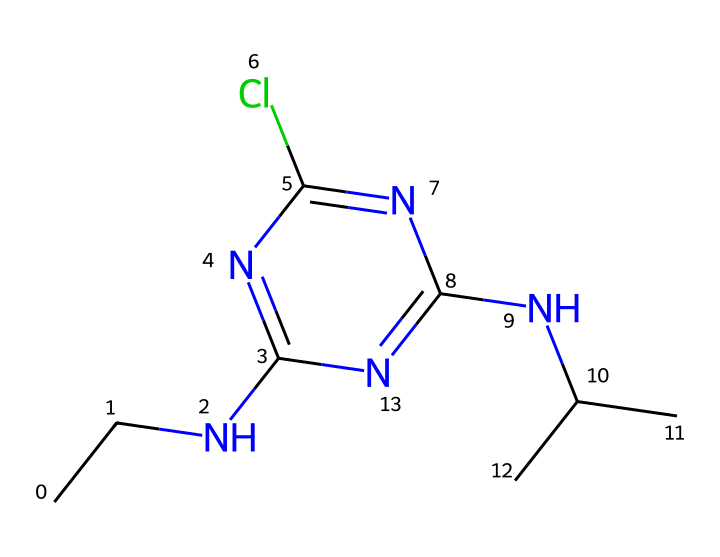What is the molecular formula of atrazine? The molecular formula can be deduced by counting the types and number of atoms represented in the SMILES. The structure shows carbon (C), hydrogen (H), chlorine (Cl), and nitrogen (N) atoms, which combine to form C8H14ClN5.
Answer: C8H14ClN5 How many nitrogen atoms are in the structure? By analyzing the SMILES, we identify five 'N' characters, indicating there are five nitrogen atoms present in the molecule.
Answer: 5 What type of chemical bond is indicated between the carbon atoms in this herbicide? The presence of directly connected carbon atoms in the SMILES suggests that these carbon atoms are linked by single covalent bonds, as there are no double or triple bond indications between them in the representation.
Answer: single covalent bonds What is the significance of the chlorine atom in atrazine? The chlorine atom is known to enhance the herbicide's ability to inhibit photosynthesis and is an important functional group in herbicides, particularly for atrazine's activity against weeds.
Answer: enhances herbicidal activity Which chemical functional group is primarily responsible for atrazine's herbicidal properties? The amine functional group, indicated by the presence of nitrogen atoms bonded to carbon chains, plays a crucial role in atrazine's function as a herbicide by affecting its interaction with biological targets in plants.
Answer: amine functional group How many carbon atoms are branched in this molecule? In the SMILES representation, the 'C(C)' indicates one branched carbon, suggesting that there are two carbon atoms at that branching point, indicating a single branch in the structure.
Answer: 1 Which element in atrazine can lead to environmental concerns? The chlorine atom is significant as it can contribute to environmental persistence and toxicity concerns associated with atrazine, creating debates regarding its use in agricultural practices.
Answer: chlorine 